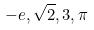Convert formula to latex. <formula><loc_0><loc_0><loc_500><loc_500>- e , \sqrt { 2 } , 3 , \pi</formula> 